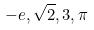Convert formula to latex. <formula><loc_0><loc_0><loc_500><loc_500>- e , \sqrt { 2 } , 3 , \pi</formula> 